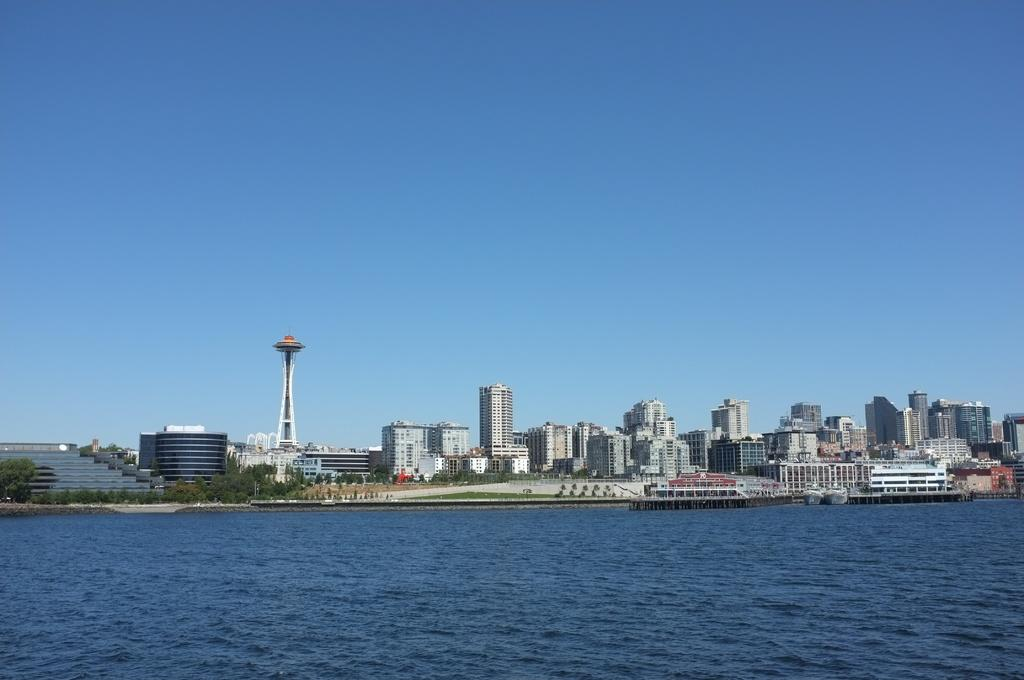What type of structures can be seen in the image? There are many buildings and a tower in the image. What natural elements are present in the image? There are trees, grass, and water visible in the image. Can you describe the architectural features in the image? There are stairs in the image. What part of the natural environment is visible in the image? The sky is visible in the image. What type of reaction can be seen happening in the water in the image? There is no reaction happening in the water in the image; it is a still body of water. What role does the society play in the construction of the buildings in the image? The image does not provide information about the society or its role in the construction of the buildings. 